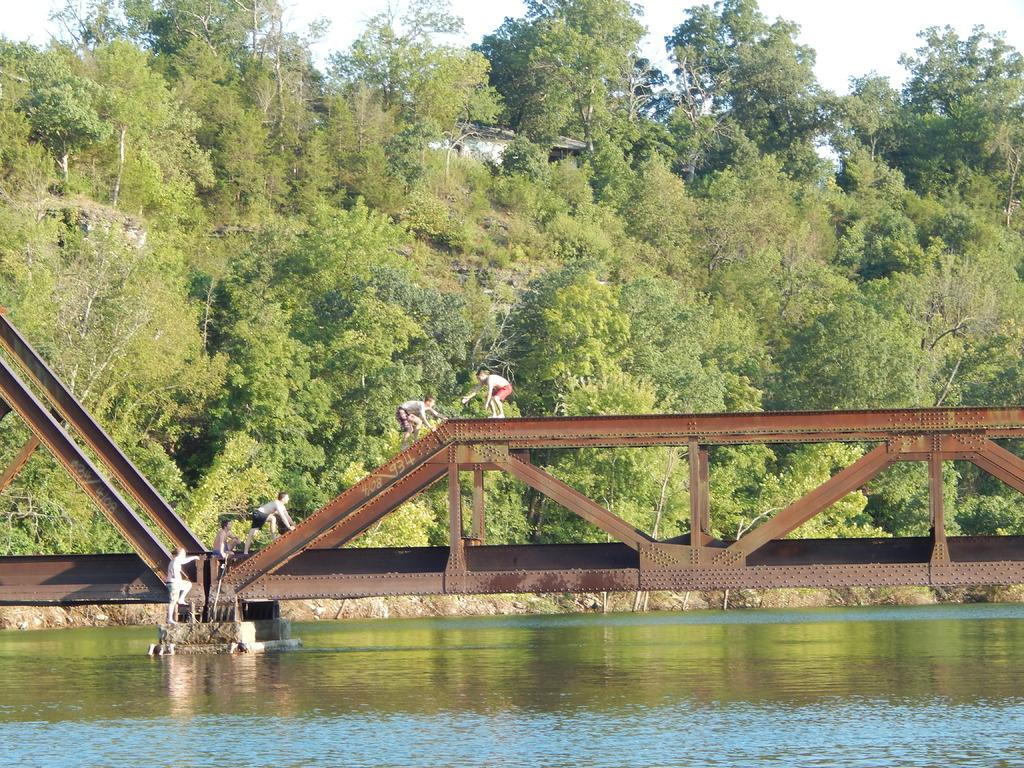What can be seen in the sky in the image? The sky is visible in the image. What type of structure is present in the image? There is a building in the image. What type of vegetation is present in the image? Trees are present in the image. What are the persons in the image doing? Some persons are standing on a bridge, while others are climbing the bridge from the water. What type of hair can be seen on the persons in the image? There is no information about the hair of the persons in the image, as the focus is on their actions and location. 